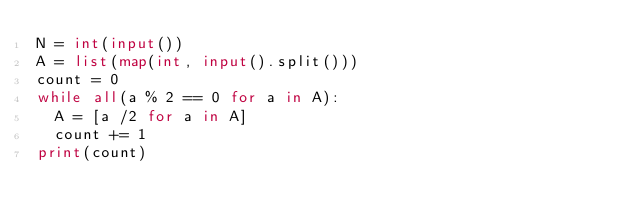<code> <loc_0><loc_0><loc_500><loc_500><_Python_>N = int(input())
A = list(map(int, input().split()))
count = 0
while all(a % 2 == 0 for a in A):
  A = [a /2 for a in A]
  count += 1
print(count)
  
</code> 